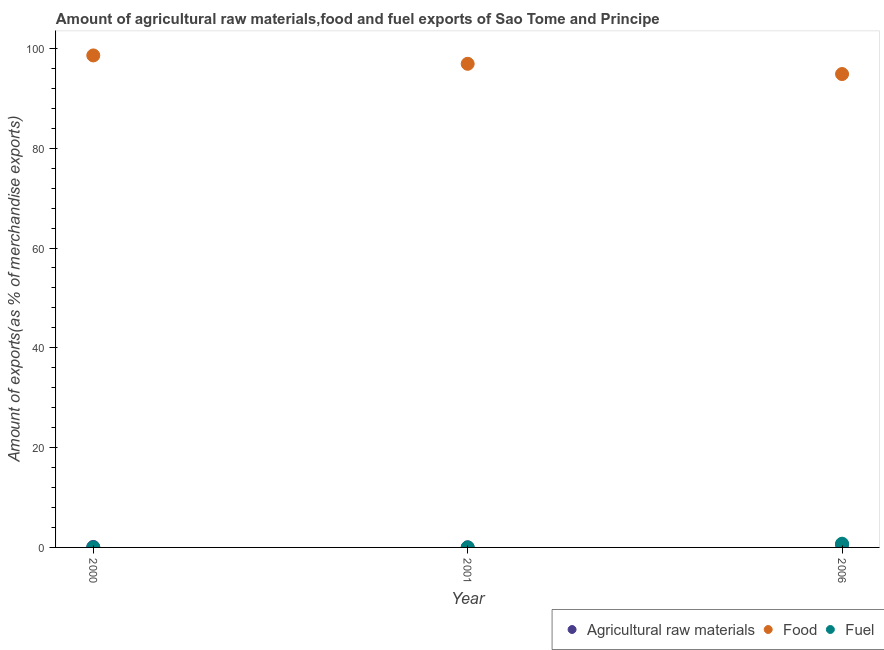Is the number of dotlines equal to the number of legend labels?
Give a very brief answer. Yes. What is the percentage of raw materials exports in 2006?
Keep it short and to the point. 0.56. Across all years, what is the maximum percentage of food exports?
Offer a very short reply. 98.6. Across all years, what is the minimum percentage of raw materials exports?
Your response must be concise. 0.02. In which year was the percentage of food exports maximum?
Provide a succinct answer. 2000. What is the total percentage of raw materials exports in the graph?
Give a very brief answer. 0.68. What is the difference between the percentage of raw materials exports in 2001 and that in 2006?
Keep it short and to the point. -0.54. What is the difference between the percentage of raw materials exports in 2006 and the percentage of food exports in 2000?
Provide a succinct answer. -98.04. What is the average percentage of food exports per year?
Your answer should be very brief. 96.8. In the year 2006, what is the difference between the percentage of fuel exports and percentage of food exports?
Keep it short and to the point. -94.12. In how many years, is the percentage of fuel exports greater than 68 %?
Ensure brevity in your answer.  0. What is the ratio of the percentage of raw materials exports in 2001 to that in 2006?
Your answer should be compact. 0.04. Is the percentage of fuel exports in 2000 less than that in 2006?
Offer a terse response. Yes. Is the difference between the percentage of fuel exports in 2000 and 2006 greater than the difference between the percentage of food exports in 2000 and 2006?
Offer a terse response. No. What is the difference between the highest and the second highest percentage of fuel exports?
Provide a succinct answer. 0.74. What is the difference between the highest and the lowest percentage of fuel exports?
Give a very brief answer. 0.75. In how many years, is the percentage of food exports greater than the average percentage of food exports taken over all years?
Give a very brief answer. 2. Is it the case that in every year, the sum of the percentage of raw materials exports and percentage of food exports is greater than the percentage of fuel exports?
Offer a very short reply. Yes. Is the percentage of food exports strictly greater than the percentage of raw materials exports over the years?
Your answer should be compact. Yes. How many years are there in the graph?
Provide a succinct answer. 3. What is the difference between two consecutive major ticks on the Y-axis?
Your answer should be compact. 20. Does the graph contain any zero values?
Provide a succinct answer. No. Where does the legend appear in the graph?
Your response must be concise. Bottom right. How many legend labels are there?
Offer a very short reply. 3. What is the title of the graph?
Offer a very short reply. Amount of agricultural raw materials,food and fuel exports of Sao Tome and Principe. What is the label or title of the Y-axis?
Ensure brevity in your answer.  Amount of exports(as % of merchandise exports). What is the Amount of exports(as % of merchandise exports) of Agricultural raw materials in 2000?
Make the answer very short. 0.1. What is the Amount of exports(as % of merchandise exports) in Food in 2000?
Give a very brief answer. 98.6. What is the Amount of exports(as % of merchandise exports) in Fuel in 2000?
Make the answer very short. 0. What is the Amount of exports(as % of merchandise exports) in Agricultural raw materials in 2001?
Make the answer very short. 0.02. What is the Amount of exports(as % of merchandise exports) in Food in 2001?
Your response must be concise. 96.92. What is the Amount of exports(as % of merchandise exports) of Fuel in 2001?
Provide a succinct answer. 0.01. What is the Amount of exports(as % of merchandise exports) of Agricultural raw materials in 2006?
Keep it short and to the point. 0.56. What is the Amount of exports(as % of merchandise exports) in Food in 2006?
Give a very brief answer. 94.87. What is the Amount of exports(as % of merchandise exports) of Fuel in 2006?
Provide a short and direct response. 0.75. Across all years, what is the maximum Amount of exports(as % of merchandise exports) in Agricultural raw materials?
Make the answer very short. 0.56. Across all years, what is the maximum Amount of exports(as % of merchandise exports) of Food?
Offer a very short reply. 98.6. Across all years, what is the maximum Amount of exports(as % of merchandise exports) in Fuel?
Provide a succinct answer. 0.75. Across all years, what is the minimum Amount of exports(as % of merchandise exports) in Agricultural raw materials?
Give a very brief answer. 0.02. Across all years, what is the minimum Amount of exports(as % of merchandise exports) in Food?
Offer a terse response. 94.87. Across all years, what is the minimum Amount of exports(as % of merchandise exports) in Fuel?
Offer a very short reply. 0. What is the total Amount of exports(as % of merchandise exports) in Agricultural raw materials in the graph?
Offer a very short reply. 0.68. What is the total Amount of exports(as % of merchandise exports) in Food in the graph?
Provide a short and direct response. 290.39. What is the total Amount of exports(as % of merchandise exports) in Fuel in the graph?
Your answer should be compact. 0.75. What is the difference between the Amount of exports(as % of merchandise exports) of Agricultural raw materials in 2000 and that in 2001?
Ensure brevity in your answer.  0.07. What is the difference between the Amount of exports(as % of merchandise exports) of Food in 2000 and that in 2001?
Ensure brevity in your answer.  1.68. What is the difference between the Amount of exports(as % of merchandise exports) of Fuel in 2000 and that in 2001?
Offer a terse response. -0.01. What is the difference between the Amount of exports(as % of merchandise exports) of Agricultural raw materials in 2000 and that in 2006?
Offer a very short reply. -0.47. What is the difference between the Amount of exports(as % of merchandise exports) of Food in 2000 and that in 2006?
Offer a very short reply. 3.73. What is the difference between the Amount of exports(as % of merchandise exports) in Fuel in 2000 and that in 2006?
Your answer should be very brief. -0.75. What is the difference between the Amount of exports(as % of merchandise exports) of Agricultural raw materials in 2001 and that in 2006?
Ensure brevity in your answer.  -0.54. What is the difference between the Amount of exports(as % of merchandise exports) in Food in 2001 and that in 2006?
Provide a short and direct response. 2.05. What is the difference between the Amount of exports(as % of merchandise exports) in Fuel in 2001 and that in 2006?
Offer a very short reply. -0.74. What is the difference between the Amount of exports(as % of merchandise exports) of Agricultural raw materials in 2000 and the Amount of exports(as % of merchandise exports) of Food in 2001?
Give a very brief answer. -96.82. What is the difference between the Amount of exports(as % of merchandise exports) in Agricultural raw materials in 2000 and the Amount of exports(as % of merchandise exports) in Fuel in 2001?
Give a very brief answer. 0.09. What is the difference between the Amount of exports(as % of merchandise exports) of Food in 2000 and the Amount of exports(as % of merchandise exports) of Fuel in 2001?
Ensure brevity in your answer.  98.59. What is the difference between the Amount of exports(as % of merchandise exports) of Agricultural raw materials in 2000 and the Amount of exports(as % of merchandise exports) of Food in 2006?
Ensure brevity in your answer.  -94.77. What is the difference between the Amount of exports(as % of merchandise exports) in Agricultural raw materials in 2000 and the Amount of exports(as % of merchandise exports) in Fuel in 2006?
Give a very brief answer. -0.65. What is the difference between the Amount of exports(as % of merchandise exports) of Food in 2000 and the Amount of exports(as % of merchandise exports) of Fuel in 2006?
Keep it short and to the point. 97.85. What is the difference between the Amount of exports(as % of merchandise exports) in Agricultural raw materials in 2001 and the Amount of exports(as % of merchandise exports) in Food in 2006?
Offer a terse response. -94.84. What is the difference between the Amount of exports(as % of merchandise exports) in Agricultural raw materials in 2001 and the Amount of exports(as % of merchandise exports) in Fuel in 2006?
Make the answer very short. -0.72. What is the difference between the Amount of exports(as % of merchandise exports) of Food in 2001 and the Amount of exports(as % of merchandise exports) of Fuel in 2006?
Give a very brief answer. 96.17. What is the average Amount of exports(as % of merchandise exports) in Agricultural raw materials per year?
Offer a terse response. 0.23. What is the average Amount of exports(as % of merchandise exports) of Food per year?
Your answer should be very brief. 96.8. What is the average Amount of exports(as % of merchandise exports) of Fuel per year?
Provide a succinct answer. 0.25. In the year 2000, what is the difference between the Amount of exports(as % of merchandise exports) in Agricultural raw materials and Amount of exports(as % of merchandise exports) in Food?
Ensure brevity in your answer.  -98.5. In the year 2000, what is the difference between the Amount of exports(as % of merchandise exports) of Agricultural raw materials and Amount of exports(as % of merchandise exports) of Fuel?
Offer a terse response. 0.1. In the year 2000, what is the difference between the Amount of exports(as % of merchandise exports) in Food and Amount of exports(as % of merchandise exports) in Fuel?
Provide a succinct answer. 98.6. In the year 2001, what is the difference between the Amount of exports(as % of merchandise exports) in Agricultural raw materials and Amount of exports(as % of merchandise exports) in Food?
Your answer should be very brief. -96.9. In the year 2001, what is the difference between the Amount of exports(as % of merchandise exports) in Agricultural raw materials and Amount of exports(as % of merchandise exports) in Fuel?
Offer a very short reply. 0.02. In the year 2001, what is the difference between the Amount of exports(as % of merchandise exports) of Food and Amount of exports(as % of merchandise exports) of Fuel?
Make the answer very short. 96.92. In the year 2006, what is the difference between the Amount of exports(as % of merchandise exports) in Agricultural raw materials and Amount of exports(as % of merchandise exports) in Food?
Ensure brevity in your answer.  -94.31. In the year 2006, what is the difference between the Amount of exports(as % of merchandise exports) of Agricultural raw materials and Amount of exports(as % of merchandise exports) of Fuel?
Give a very brief answer. -0.18. In the year 2006, what is the difference between the Amount of exports(as % of merchandise exports) of Food and Amount of exports(as % of merchandise exports) of Fuel?
Offer a terse response. 94.12. What is the ratio of the Amount of exports(as % of merchandise exports) in Agricultural raw materials in 2000 to that in 2001?
Ensure brevity in your answer.  4.28. What is the ratio of the Amount of exports(as % of merchandise exports) in Food in 2000 to that in 2001?
Keep it short and to the point. 1.02. What is the ratio of the Amount of exports(as % of merchandise exports) in Fuel in 2000 to that in 2001?
Ensure brevity in your answer.  0.02. What is the ratio of the Amount of exports(as % of merchandise exports) of Agricultural raw materials in 2000 to that in 2006?
Provide a succinct answer. 0.17. What is the ratio of the Amount of exports(as % of merchandise exports) in Food in 2000 to that in 2006?
Make the answer very short. 1.04. What is the ratio of the Amount of exports(as % of merchandise exports) in Agricultural raw materials in 2001 to that in 2006?
Your response must be concise. 0.04. What is the ratio of the Amount of exports(as % of merchandise exports) in Food in 2001 to that in 2006?
Keep it short and to the point. 1.02. What is the ratio of the Amount of exports(as % of merchandise exports) of Fuel in 2001 to that in 2006?
Offer a very short reply. 0.01. What is the difference between the highest and the second highest Amount of exports(as % of merchandise exports) in Agricultural raw materials?
Provide a short and direct response. 0.47. What is the difference between the highest and the second highest Amount of exports(as % of merchandise exports) in Food?
Ensure brevity in your answer.  1.68. What is the difference between the highest and the second highest Amount of exports(as % of merchandise exports) in Fuel?
Provide a short and direct response. 0.74. What is the difference between the highest and the lowest Amount of exports(as % of merchandise exports) in Agricultural raw materials?
Keep it short and to the point. 0.54. What is the difference between the highest and the lowest Amount of exports(as % of merchandise exports) of Food?
Make the answer very short. 3.73. What is the difference between the highest and the lowest Amount of exports(as % of merchandise exports) in Fuel?
Offer a very short reply. 0.75. 